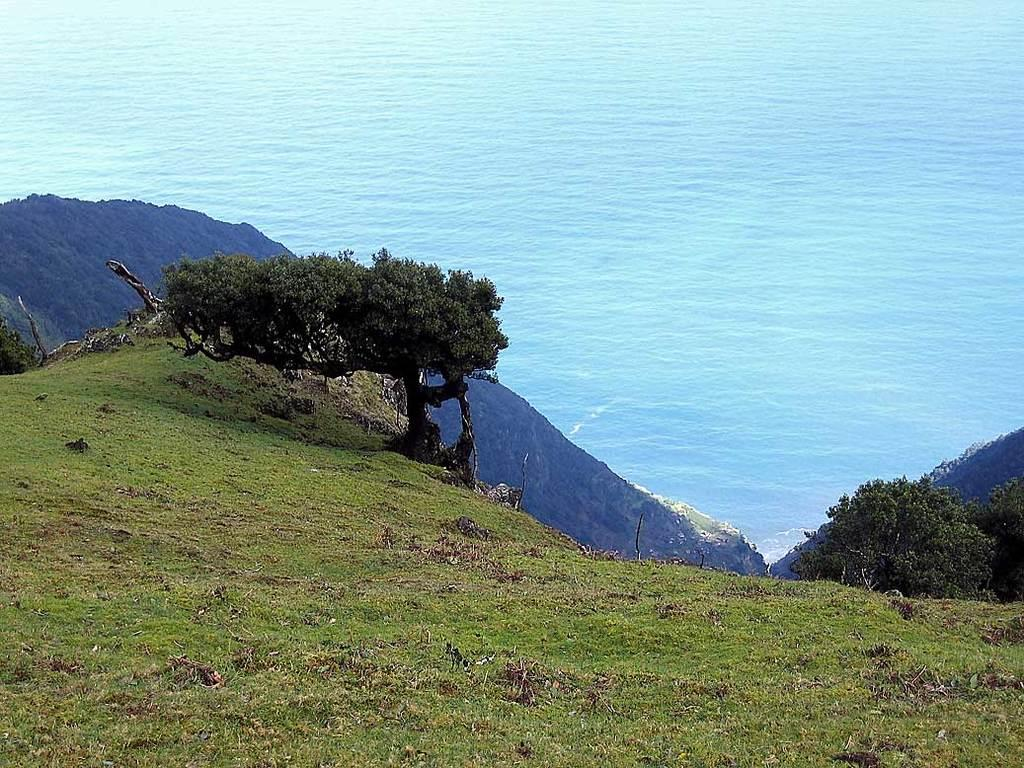What type of vegetation can be seen in the image? There is grass in the image. Are there any other plants visible in the image? Yes, there are trees in the image. How are the trees positioned in the image? The trees are in front of the scene. What can be seen in the background of the image? There is water visible in the background of the image. What rhythm is the grass following in the image? The grass does not follow a rhythm in the image; it is stationary vegetation. 